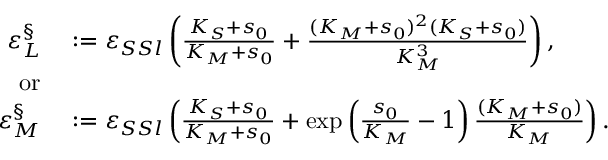<formula> <loc_0><loc_0><loc_500><loc_500>\begin{array} { r l } { \varepsilon _ { L } ^ { \S } } & \colon = \varepsilon _ { S S l } \left ( \frac { K _ { S } + s _ { 0 } } { K _ { M } + s _ { 0 } } + \frac { ( K _ { M } + s _ { 0 } ) ^ { 2 } ( K _ { S } + s _ { 0 } ) } { K _ { M } ^ { 3 } } \right ) , } \\ { o r } \\ { \varepsilon _ { M } ^ { \S } } & \colon = \varepsilon _ { S S l } \left ( \frac { K _ { S } + s _ { 0 } } { K _ { M } + s _ { 0 } } + \exp \left ( \frac { s _ { 0 } } { K _ { M } } - 1 \right ) \frac { ( K _ { M } + s _ { 0 } ) } { K _ { M } } \right ) . } \end{array}</formula> 